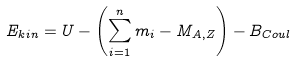<formula> <loc_0><loc_0><loc_500><loc_500>E _ { k i n } = U - \left ( \sum _ { i = 1 } ^ { n } m _ { i } - M _ { A , Z } \right ) - B _ { C o u l }</formula> 